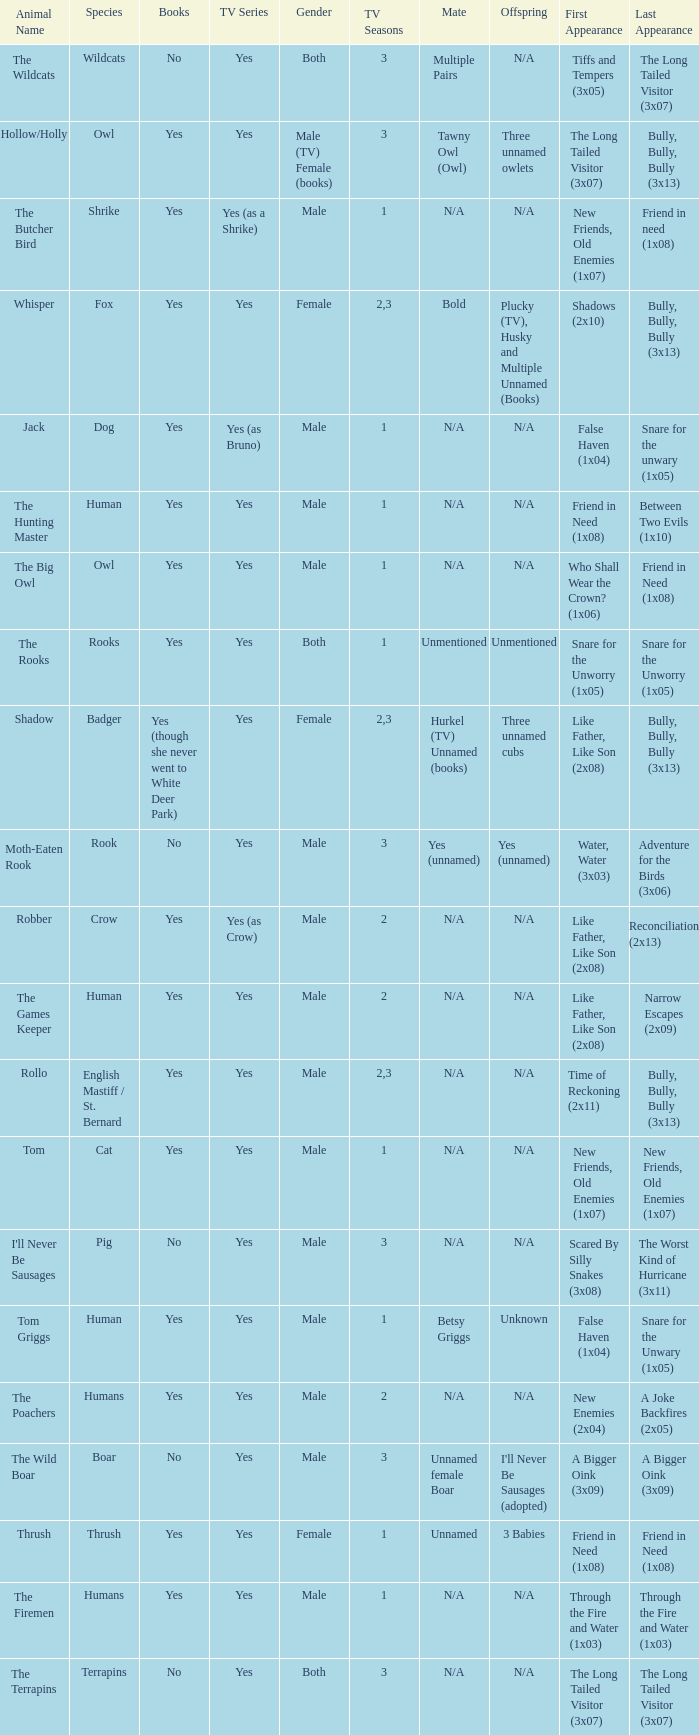What is the mate for Last Appearance of bully, bully, bully (3x13) for the animal named hollow/holly later than season 1? Tawny Owl (Owl). 